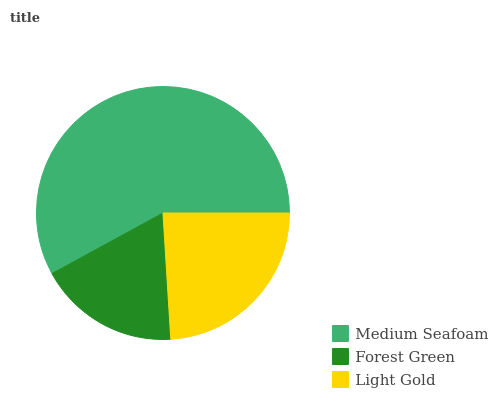Is Forest Green the minimum?
Answer yes or no. Yes. Is Medium Seafoam the maximum?
Answer yes or no. Yes. Is Light Gold the minimum?
Answer yes or no. No. Is Light Gold the maximum?
Answer yes or no. No. Is Light Gold greater than Forest Green?
Answer yes or no. Yes. Is Forest Green less than Light Gold?
Answer yes or no. Yes. Is Forest Green greater than Light Gold?
Answer yes or no. No. Is Light Gold less than Forest Green?
Answer yes or no. No. Is Light Gold the high median?
Answer yes or no. Yes. Is Light Gold the low median?
Answer yes or no. Yes. Is Forest Green the high median?
Answer yes or no. No. Is Medium Seafoam the low median?
Answer yes or no. No. 